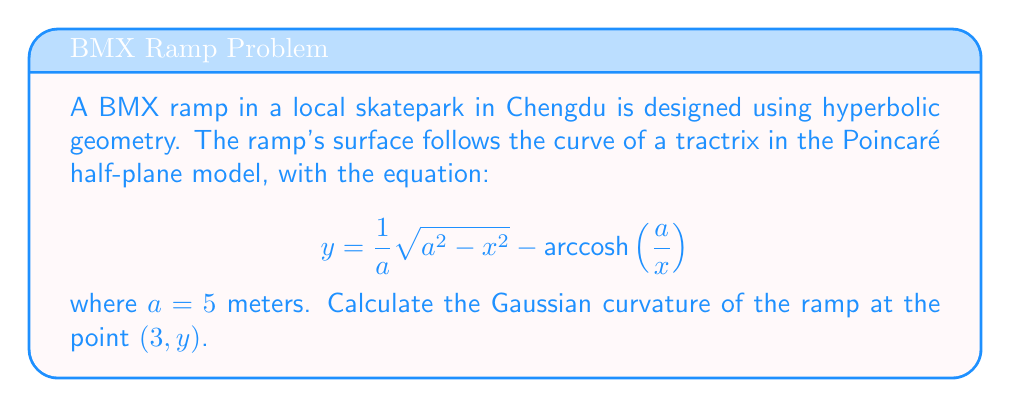Show me your answer to this math problem. To calculate the Gaussian curvature of the BMX ramp, we'll follow these steps:

1) In the Poincaré half-plane model, the Gaussian curvature $K$ is given by:

   $$K = -\frac{1}{y^2}$$

   where $y$ is the y-coordinate of the point in question.

2) We need to find $y$ when $x = 3$. Let's substitute the given values into the tractrix equation:

   $$y = \frac{1}{5} \sqrt{5^2 - 3^2} - \text{arccosh}\left(\frac{5}{3}\right)$$

3) Simplify:
   $$y = \frac{1}{5} \sqrt{25 - 9} - \text{arccosh}\left(\frac{5}{3}\right)$$
   $$y = \frac{1}{5} \sqrt{16} - \text{arccosh}\left(\frac{5}{3}\right)$$
   $$y = \frac{4}{5} - \text{arccosh}\left(\frac{5}{3}\right)$$

4) Calculate $\text{arccosh}\left(\frac{5}{3}\right)$:
   $$\text{arccosh}\left(\frac{5}{3}\right) \approx 0.9624$$

5) Therefore:
   $$y \approx 0.8 - 0.9624 \approx -0.1624$$

6) Now we can calculate the Gaussian curvature:

   $$K = -\frac{1}{y^2} = -\frac{1}{(-0.1624)^2} \approx -37.9$$

The negative sign indicates that the surface has negative curvature, which is characteristic of hyperbolic geometry.
Answer: $K \approx -37.9$ m^(-2) 